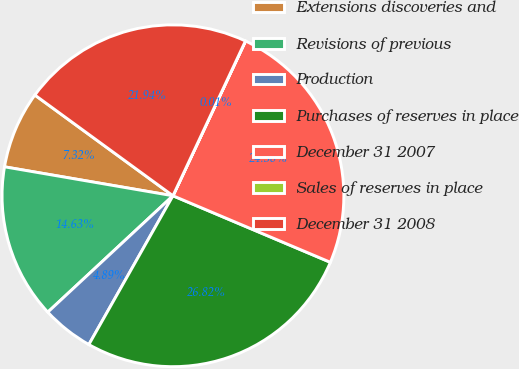<chart> <loc_0><loc_0><loc_500><loc_500><pie_chart><fcel>Extensions discoveries and<fcel>Revisions of previous<fcel>Production<fcel>Purchases of reserves in place<fcel>December 31 2007<fcel>Sales of reserves in place<fcel>December 31 2008<nl><fcel>7.32%<fcel>14.63%<fcel>4.89%<fcel>26.82%<fcel>24.38%<fcel>0.01%<fcel>21.94%<nl></chart> 